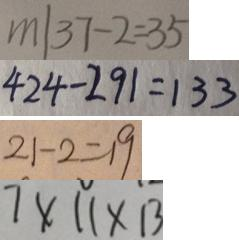<formula> <loc_0><loc_0><loc_500><loc_500>m \vert 3 7 - 2 = 3 5 
 4 2 4 - 2 9 1 = 1 3 3 
 2 1 - 2 = 1 9 
 7 \times 1 1 \times 1 3</formula> 